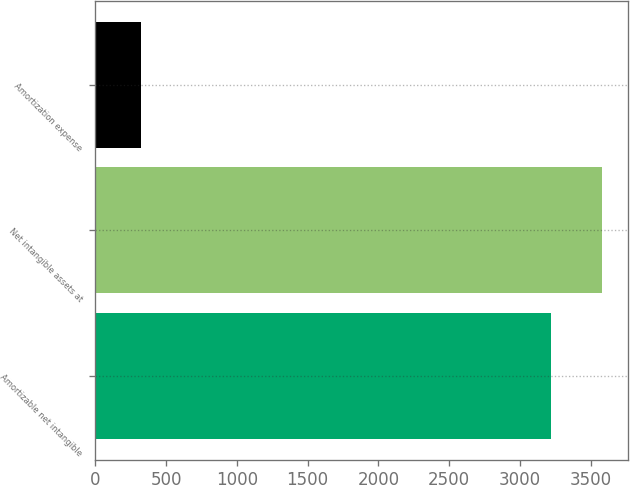Convert chart. <chart><loc_0><loc_0><loc_500><loc_500><bar_chart><fcel>Amortizable net intangible<fcel>Net intangible assets at<fcel>Amortization expense<nl><fcel>3221<fcel>3582<fcel>322<nl></chart> 